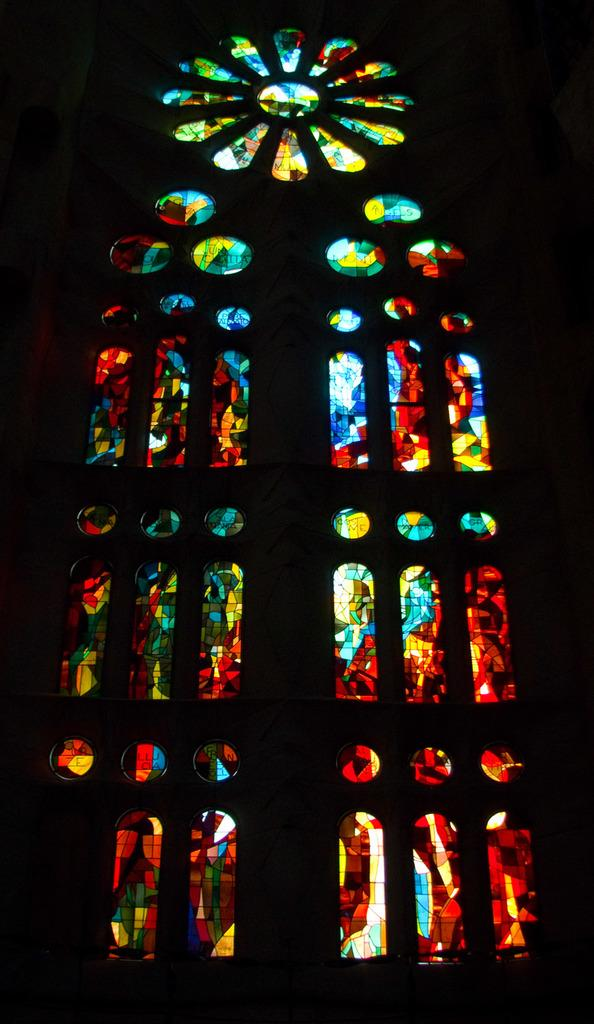What is the main subject in the center of the image? There is a stained glass in the center of the image. Can you describe the appearance of the stained glass? Unfortunately, the appearance of the stained glass cannot be described without more information about its design or colors. Is there any context or setting provided for the stained glass in the image? No, the image only shows the stained glass without any surrounding context or setting. Who is the owner of the attraction depicted in the stained glass? There is no attraction depicted in the stained glass, as it is the main subject of the image itself. 